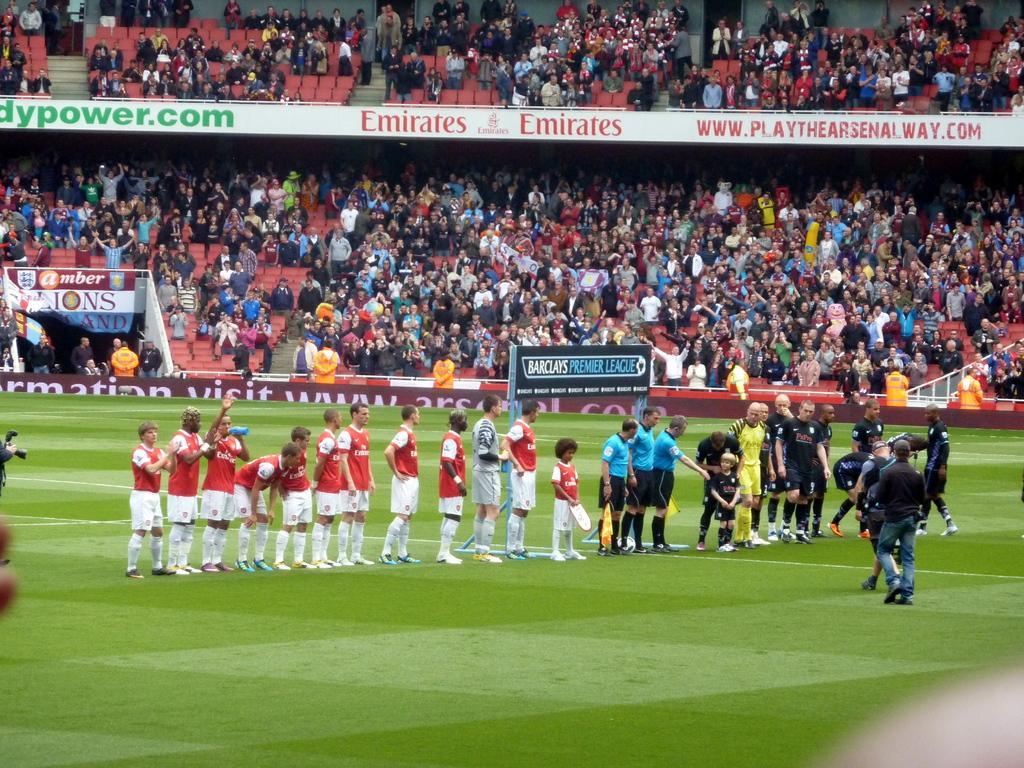<image>
Present a compact description of the photo's key features. A sign for Emirates is on the balcony level of this sports stadium. 